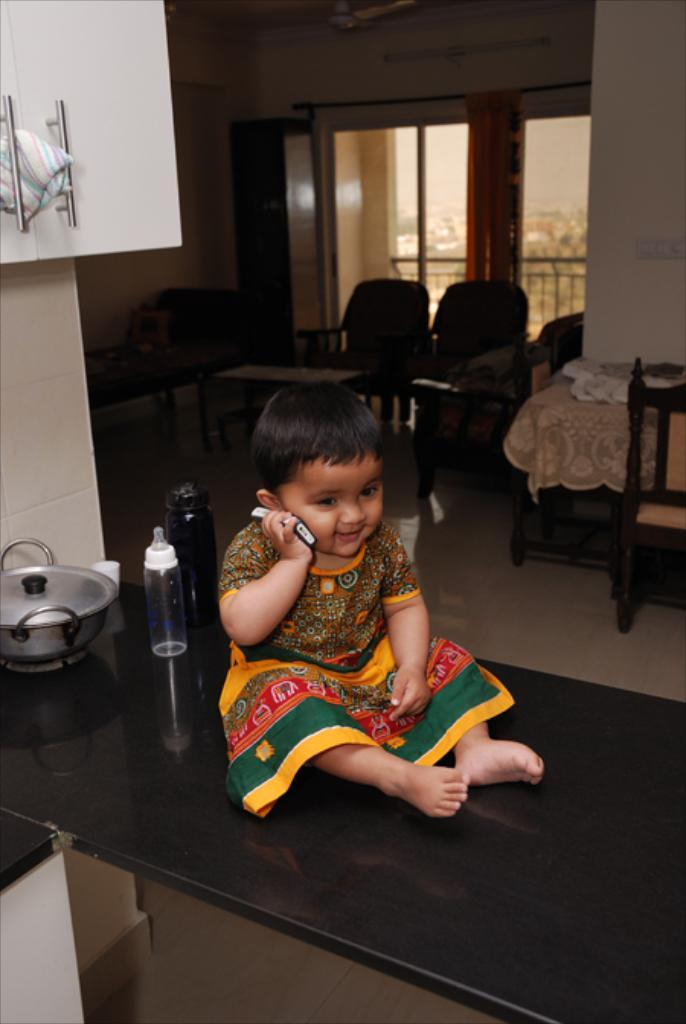Who is the main subject in the image? There is a girl in the image. What is the girl doing in the image? The girl is sitting on a table. What is the girl holding in the image? The girl is holding a phone. What can be seen in the background of the image? There is furniture, a glass window, and curtains in the background of the image. What else is present on the table in the image? There are objects on the table. What type of hose can be seen connected to the wheel in the image? There is no hose or wheel present in the image. What is the sun's position in the image? The sun is not visible in the image. 